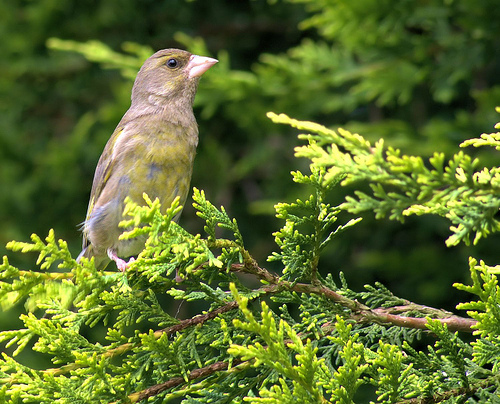Could you describe the habitat in which this bird is found? Sure! The European Greenfinch is often found in woodlands, hedgerows, gardens, and parks across Europe and western Asia. They prefer habitats with a mix of trees and open areas for foraging on the ground. 